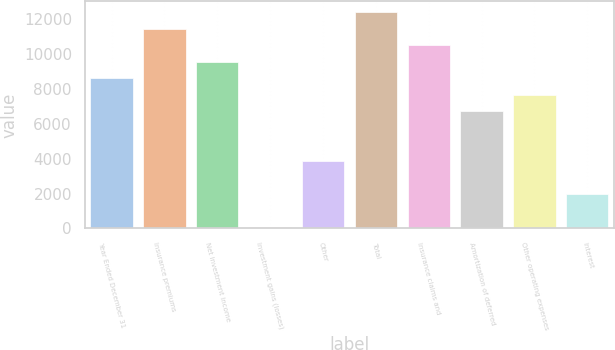<chart> <loc_0><loc_0><loc_500><loc_500><bar_chart><fcel>Year Ended December 31<fcel>Insurance premiums<fcel>Net investment income<fcel>Investment gains (losses)<fcel>Other<fcel>Total<fcel>Insurance claims and<fcel>Amortization of deferred<fcel>Other operating expenses<fcel>Interest<nl><fcel>8598.3<fcel>11444.4<fcel>9547<fcel>60<fcel>3854.8<fcel>12393.1<fcel>10495.7<fcel>6700.9<fcel>7649.6<fcel>1957.4<nl></chart> 